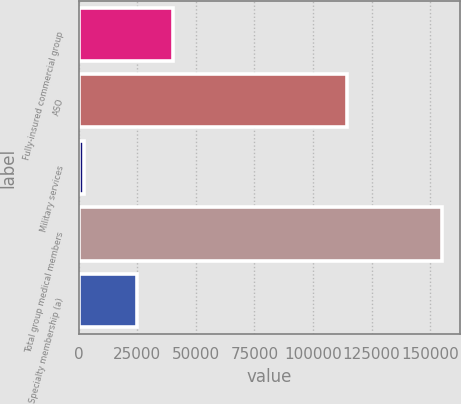<chart> <loc_0><loc_0><loc_500><loc_500><bar_chart><fcel>Fully-insured commercial group<fcel>ASO<fcel>Military services<fcel>Total group medical members<fcel>Specialty membership (a)<nl><fcel>40080<fcel>114500<fcel>2300<fcel>155100<fcel>24800<nl></chart> 